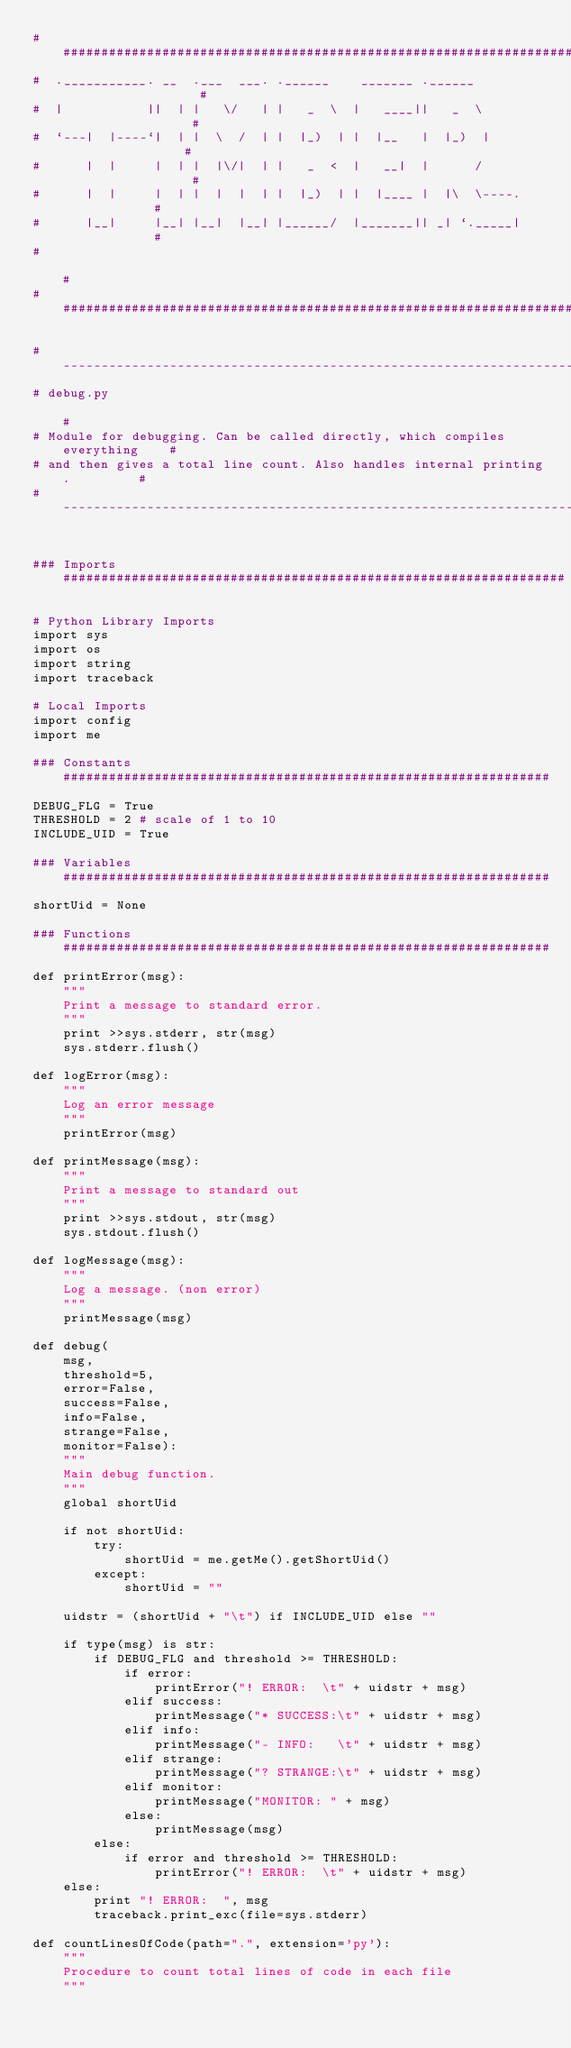Convert code to text. <code><loc_0><loc_0><loc_500><loc_500><_Python_>##############################################################################
#  .___________. __  .___  ___. .______    _______ .______                   #
#  |           ||  | |   \/   | |   _  \  |   ____||   _  \                  #
#  `---|  |----`|  | |  \  /  | |  |_)  | |  |__   |  |_)  |                 #
#      |  |     |  | |  |\/|  | |   _  <  |   __|  |      /                  #
#      |  |     |  | |  |  |  | |  |_)  | |  |____ |  |\  \----.             #
#      |__|     |__| |__|  |__| |______/  |_______|| _| `._____|             #
#                                                                            #
##############################################################################

#----------------------------------------------------------------------------#
# debug.py                                                                   #
# Module for debugging. Can be called directly, which compiles everything    #
# and then gives a total line count. Also handles internal printing.         #
#----------------------------------------------------------------------------#


### Imports ##################################################################

# Python Library Imports
import sys
import os
import string
import traceback

# Local Imports
import config
import me

### Constants ################################################################
DEBUG_FLG = True
THRESHOLD = 2 # scale of 1 to 10
INCLUDE_UID = True

### Variables ################################################################
shortUid = None

### Functions ################################################################
def printError(msg):
    """
    Print a message to standard error.
    """
    print >>sys.stderr, str(msg)
    sys.stderr.flush()

def logError(msg):
    """
    Log an error message
    """
    printError(msg)

def printMessage(msg):
    """
    Print a message to standard out
    """
    print >>sys.stdout, str(msg)
    sys.stdout.flush()

def logMessage(msg):
    """
    Log a message. (non error)
    """
    printMessage(msg)

def debug(
    msg, 
    threshold=5, 
    error=False, 
    success=False, 
    info=False, 
    strange=False,
    monitor=False):
    """
    Main debug function.
    """
    global shortUid

    if not shortUid:
        try:
            shortUid = me.getMe().getShortUid()
        except:
            shortUid = ""

    uidstr = (shortUid + "\t") if INCLUDE_UID else ""

    if type(msg) is str:
        if DEBUG_FLG and threshold >= THRESHOLD:
            if error:
                printError("! ERROR:  \t" + uidstr + msg)
            elif success:
                printMessage("* SUCCESS:\t" + uidstr + msg)
            elif info:
                printMessage("- INFO:   \t" + uidstr + msg)
            elif strange:
                printMessage("? STRANGE:\t" + uidstr + msg)
            elif monitor:
                printMessage("MONITOR: " + msg)
            else:
                printMessage(msg)
        else:
            if error and threshold >= THRESHOLD:
                printError("! ERROR:  \t" + uidstr + msg)
    else:
        print "! ERROR:  ", msg
        traceback.print_exc(file=sys.stderr)

def countLinesOfCode(path=".", extension='py'):
    """
    Procedure to count total lines of code in each file
    """</code> 